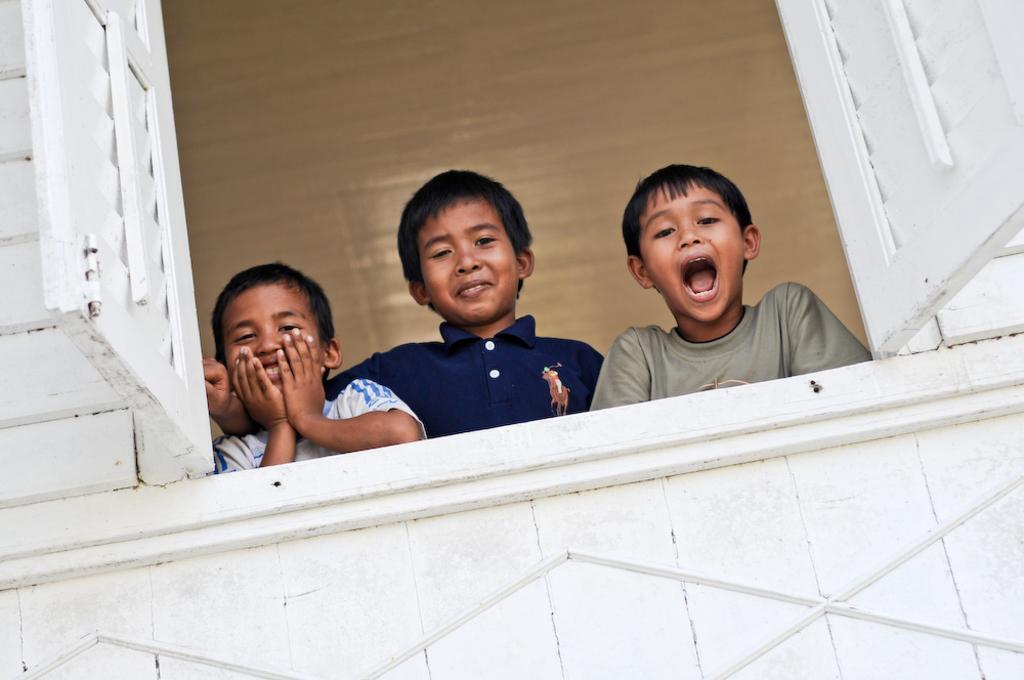Please provide a concise description of this image. Here I can see a window to the wall. Behind the window three children are smiling and giving pose for the picture. 